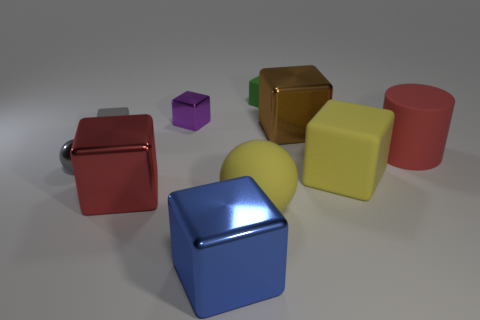Subtract all big yellow blocks. How many blocks are left? 6 Subtract all yellow spheres. How many spheres are left? 1 Subtract 3 blocks. How many blocks are left? 4 Subtract all spheres. How many objects are left? 8 Subtract all blue cylinders. Subtract all brown cubes. How many cylinders are left? 1 Subtract all brown spheres. How many red blocks are left? 1 Subtract all large blue things. Subtract all red objects. How many objects are left? 7 Add 9 red metal cubes. How many red metal cubes are left? 10 Add 2 cyan matte cubes. How many cyan matte cubes exist? 2 Subtract 0 purple cylinders. How many objects are left? 10 